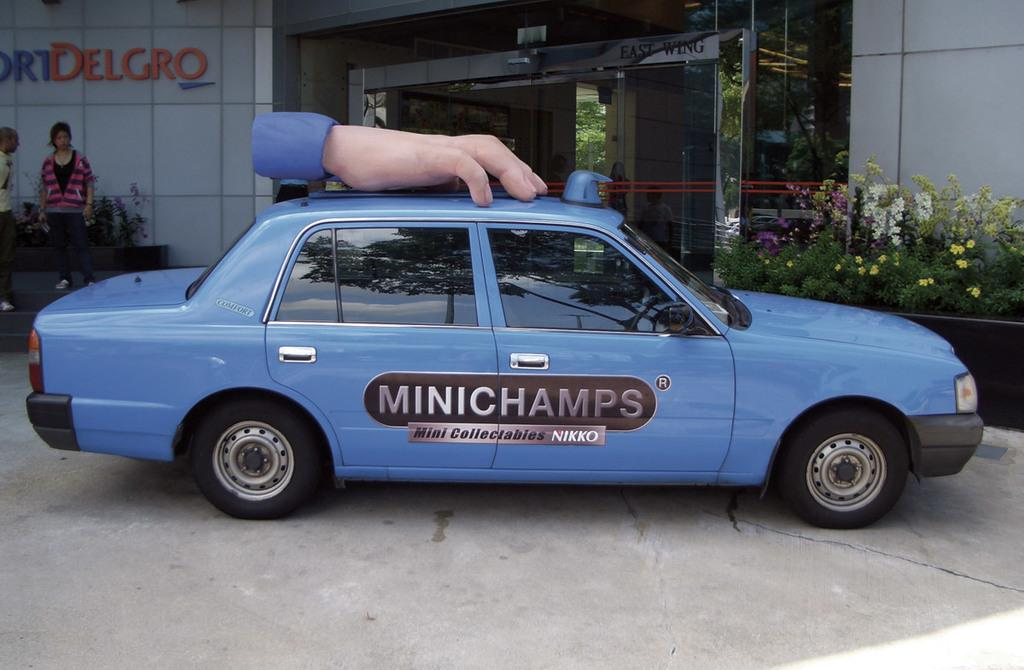<image>
Present a compact description of the photo's key features. The ad on the side of the blue car is for MiniChamps 